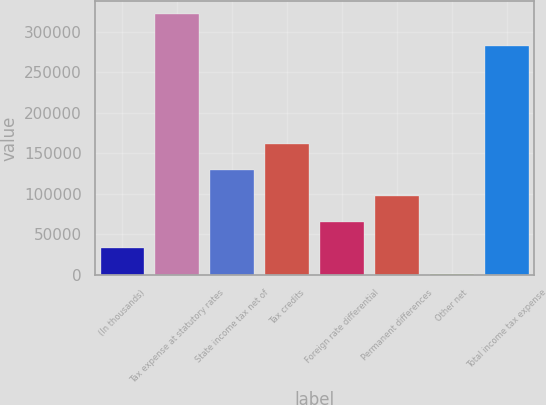Convert chart. <chart><loc_0><loc_0><loc_500><loc_500><bar_chart><fcel>(In thousands)<fcel>Tax expense at statutory rates<fcel>State income tax net of<fcel>Tax credits<fcel>Foreign rate differential<fcel>Permanent differences<fcel>Other net<fcel>Total income tax expense<nl><fcel>33465.5<fcel>321452<fcel>129461<fcel>161460<fcel>65464<fcel>97462.5<fcel>1467<fcel>281950<nl></chart> 